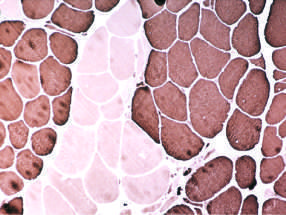what appear that all share the same fiber type (fiber type grouping) with ongoing denervation and reinnervation?
Answer the question using a single word or phrase. Large clusters of fibers 